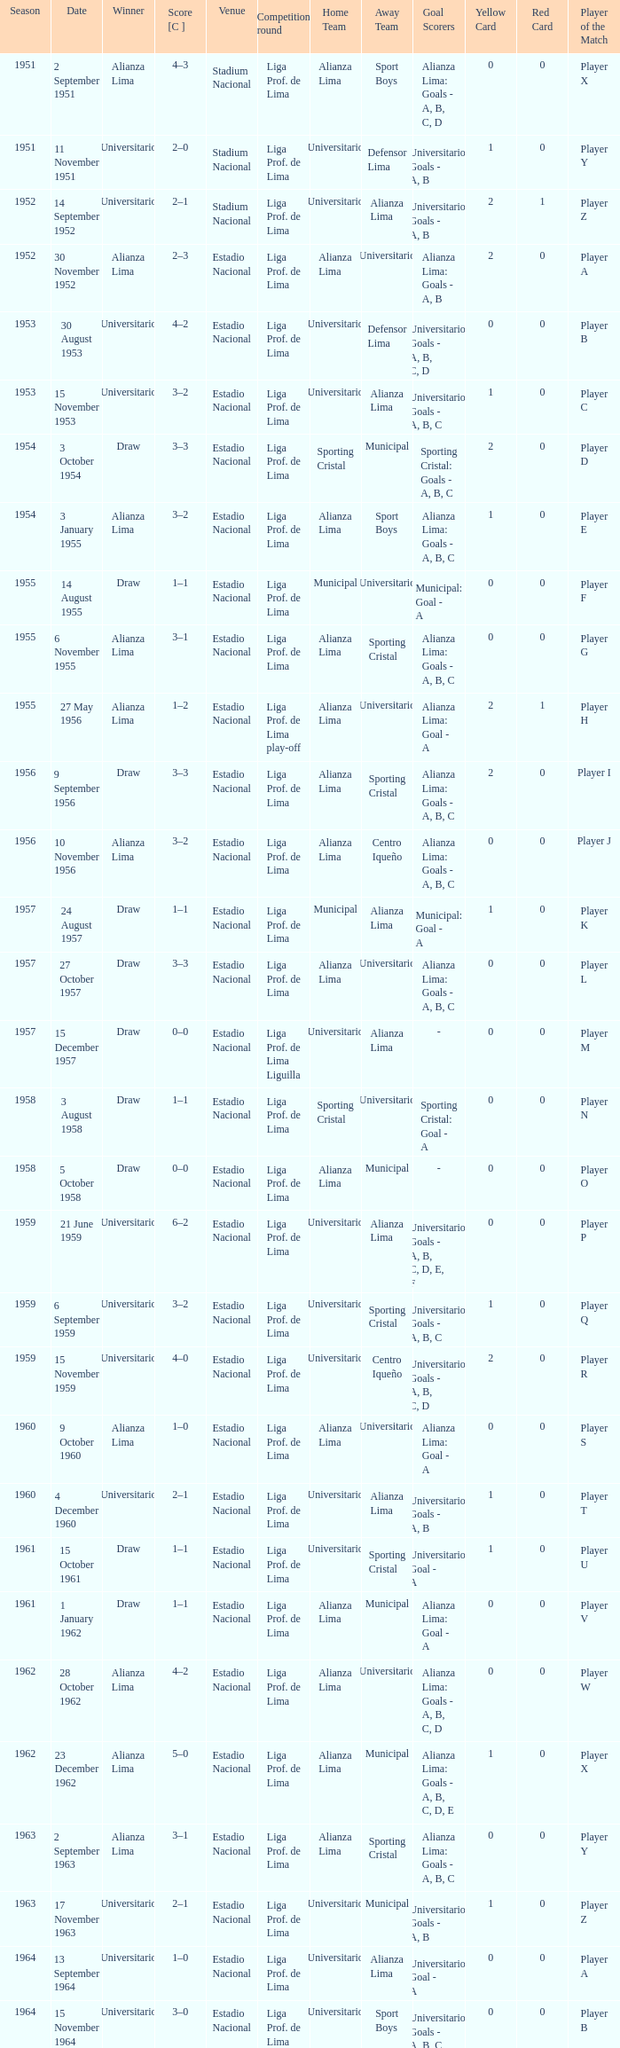What venue had an event on 17 November 1963? Estadio Nacional. 